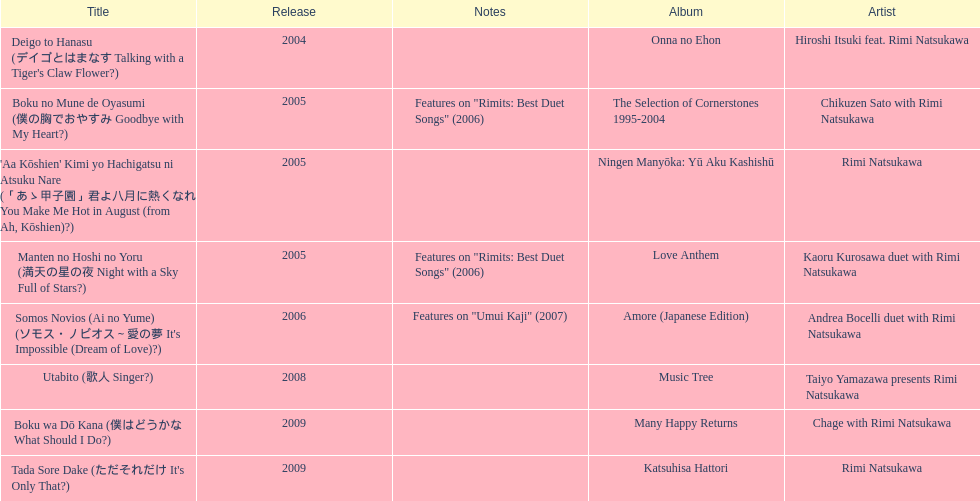Which was released earlier, deigo to hanasu or utabito? Deigo to Hanasu. 